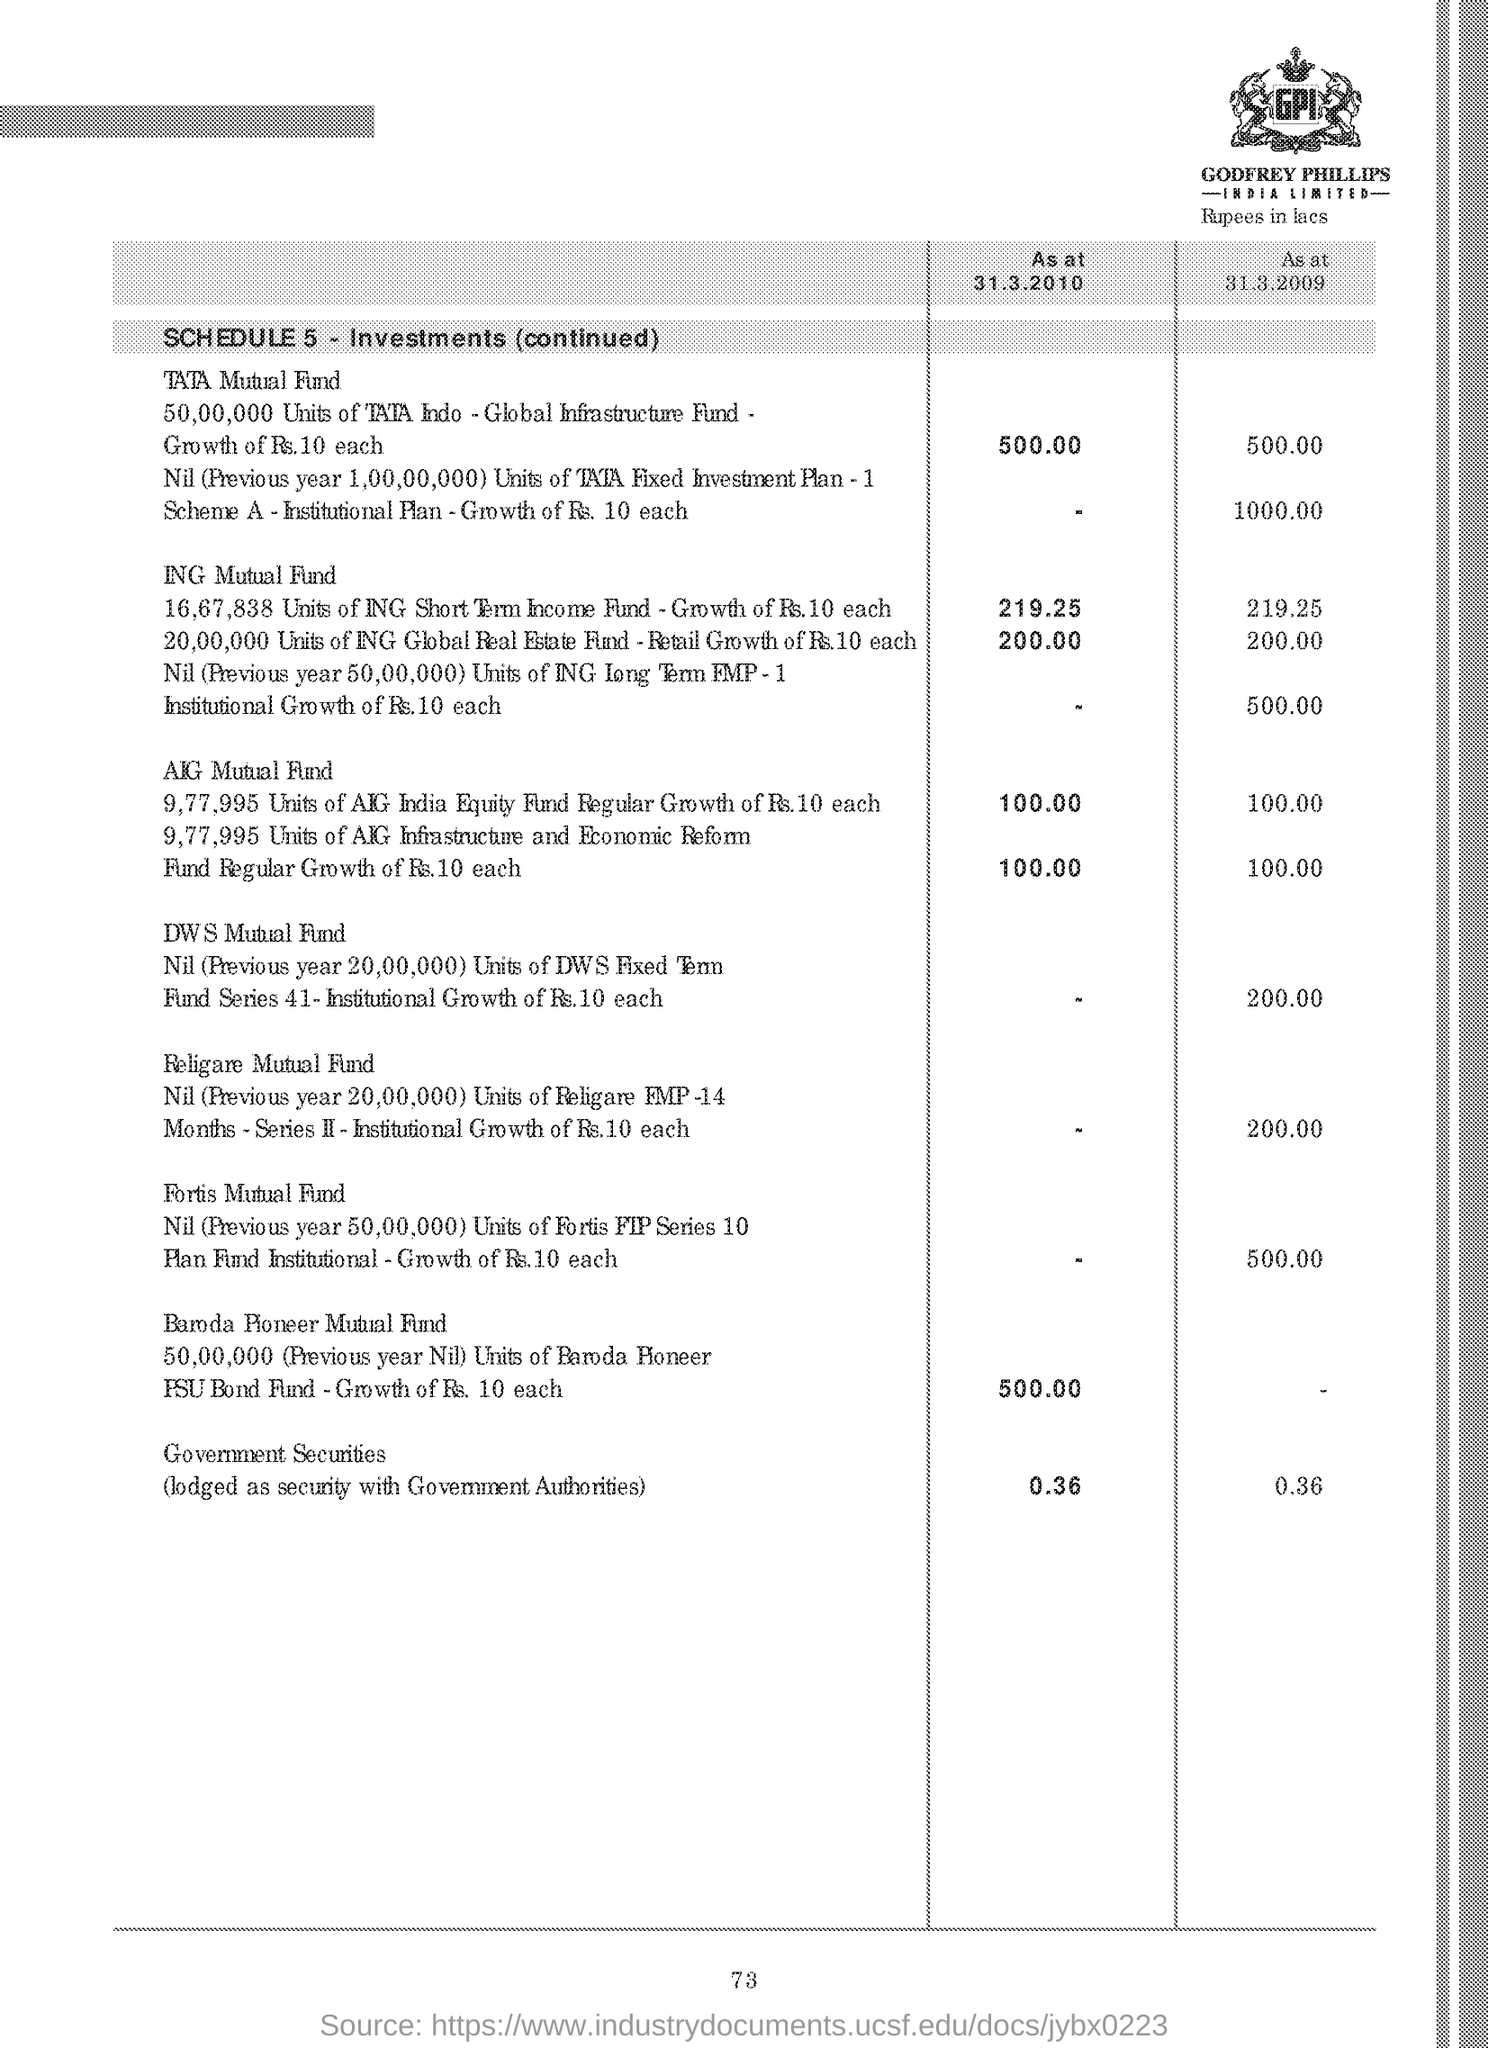Highlight a few significant elements in this photo. The page number is 73," the speaker declared. 